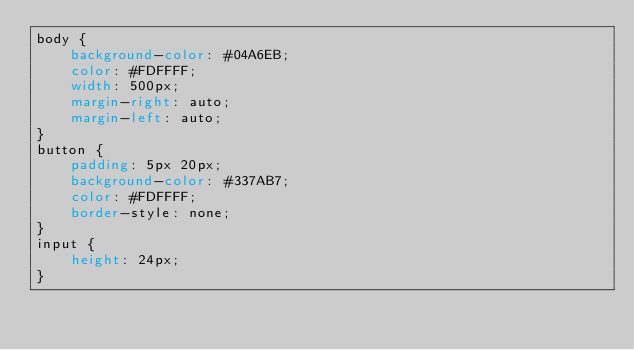Convert code to text. <code><loc_0><loc_0><loc_500><loc_500><_CSS_>body {
    background-color: #04A6EB;
    color: #FDFFFF;
    width: 500px;
    margin-right: auto;
    margin-left: auto;
}
button {
    padding: 5px 20px;
    background-color: #337AB7;
    color: #FDFFFF;
    border-style: none;
}
input {
    height: 24px;
}
</code> 